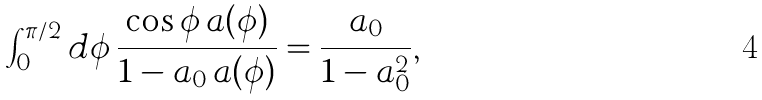Convert formula to latex. <formula><loc_0><loc_0><loc_500><loc_500>\int _ { 0 } ^ { \pi / 2 } d \phi \, \frac { \cos \phi \, a ( \phi ) } { 1 - a _ { 0 } \, a ( \phi ) } = \frac { a _ { 0 } } { 1 - a _ { 0 } ^ { 2 } } ,</formula> 